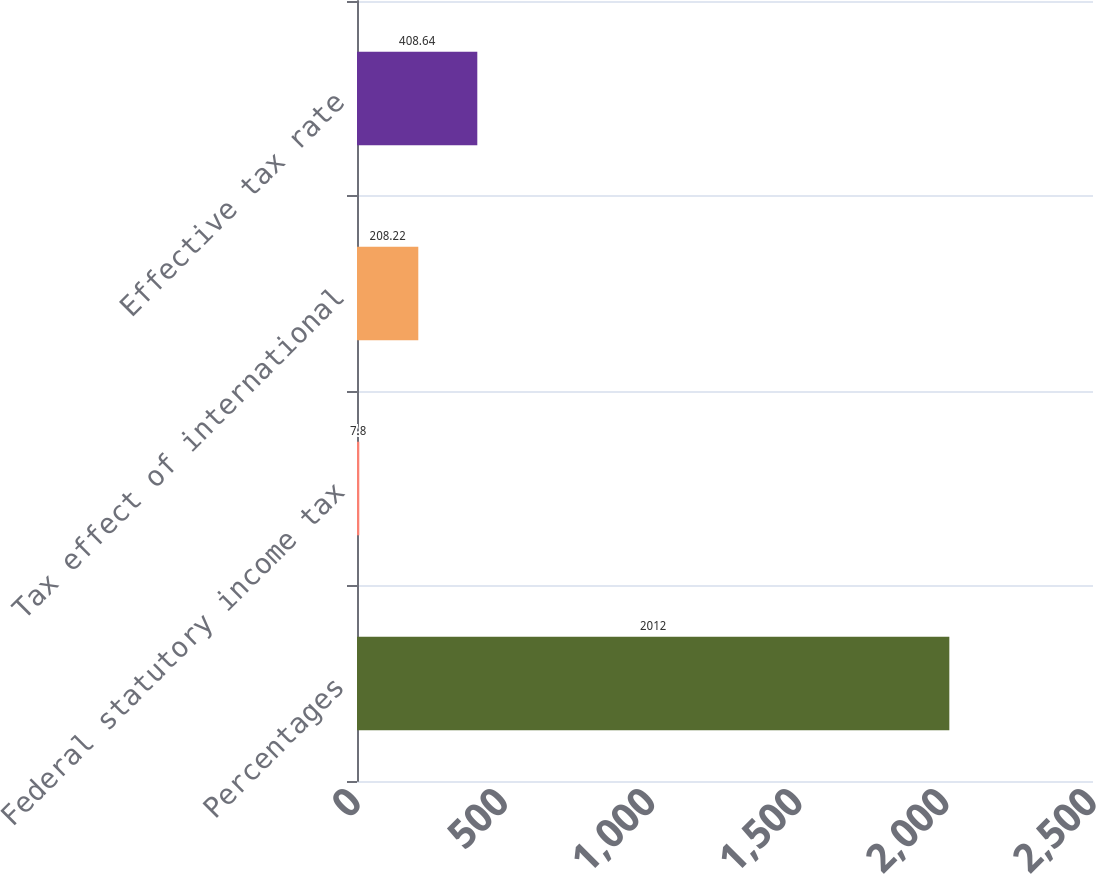Convert chart to OTSL. <chart><loc_0><loc_0><loc_500><loc_500><bar_chart><fcel>Percentages<fcel>Federal statutory income tax<fcel>Tax effect of international<fcel>Effective tax rate<nl><fcel>2012<fcel>7.8<fcel>208.22<fcel>408.64<nl></chart> 